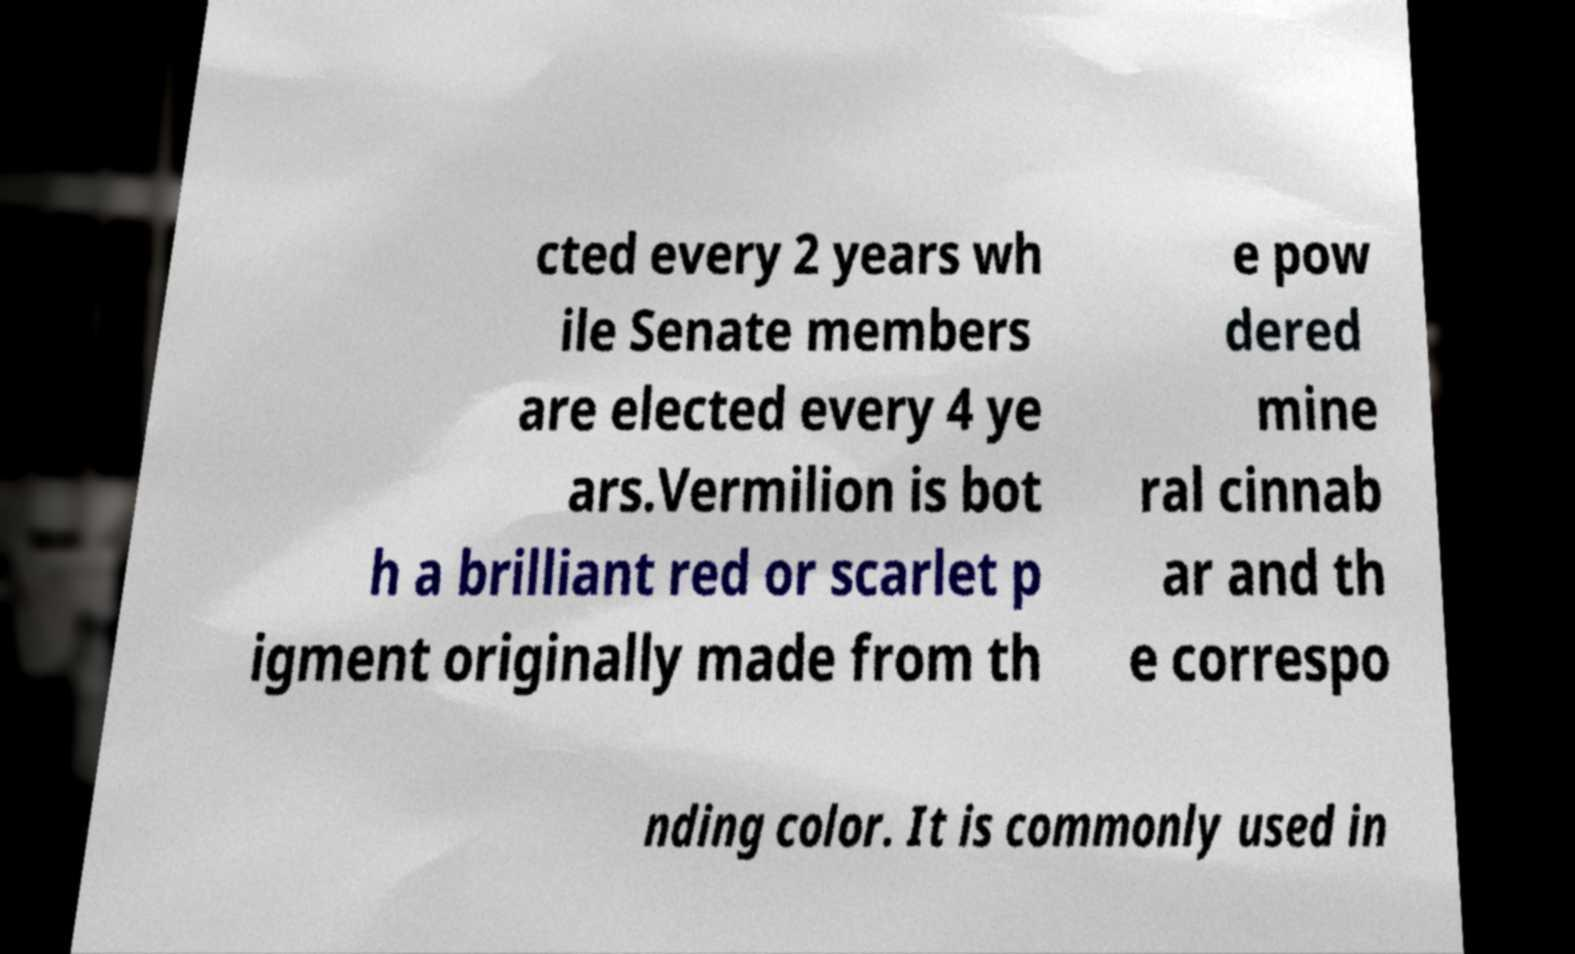There's text embedded in this image that I need extracted. Can you transcribe it verbatim? cted every 2 years wh ile Senate members are elected every 4 ye ars.Vermilion is bot h a brilliant red or scarlet p igment originally made from th e pow dered mine ral cinnab ar and th e correspo nding color. It is commonly used in 